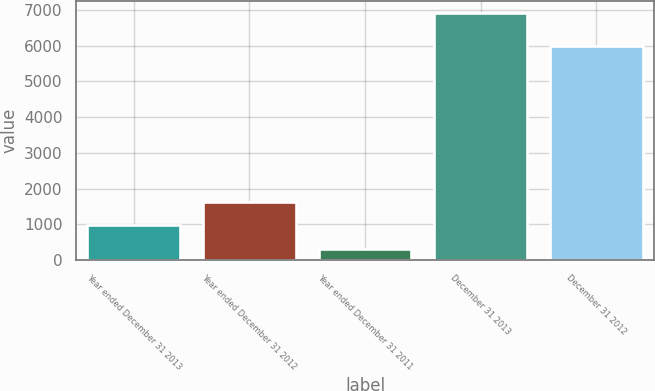Convert chart. <chart><loc_0><loc_0><loc_500><loc_500><bar_chart><fcel>Year ended December 31 2013<fcel>Year ended December 31 2012<fcel>Year ended December 31 2011<fcel>December 31 2013<fcel>December 31 2012<nl><fcel>976.05<fcel>1635.8<fcel>316.3<fcel>6913.8<fcel>5991.5<nl></chart> 